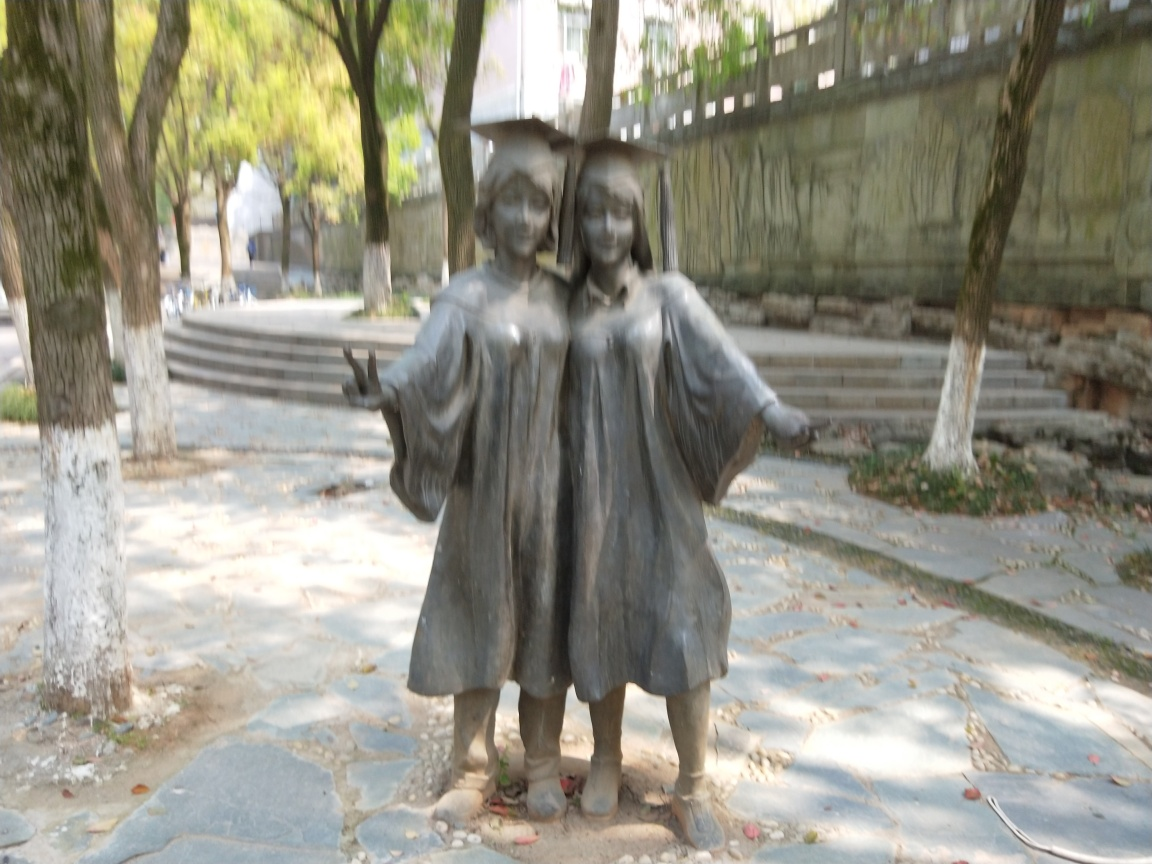Is the background of this image clear?
A. Yes
B. No B. No, the background of the image is not clear. It appears blurred, which suggests that the focus might be on the foreground, typically to draw attention to the primary subjects in the image, which in this case is the statue of two figures. 